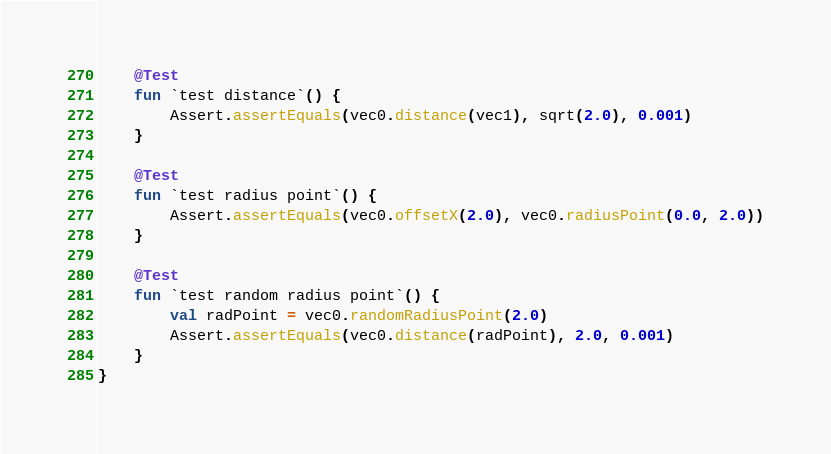<code> <loc_0><loc_0><loc_500><loc_500><_Kotlin_>
    @Test
    fun `test distance`() {
        Assert.assertEquals(vec0.distance(vec1), sqrt(2.0), 0.001)
    }

    @Test
    fun `test radius point`() {
        Assert.assertEquals(vec0.offsetX(2.0), vec0.radiusPoint(0.0, 2.0))
    }

    @Test
    fun `test random radius point`() {
        val radPoint = vec0.randomRadiusPoint(2.0)
        Assert.assertEquals(vec0.distance(radPoint), 2.0, 0.001)
    }
}</code> 